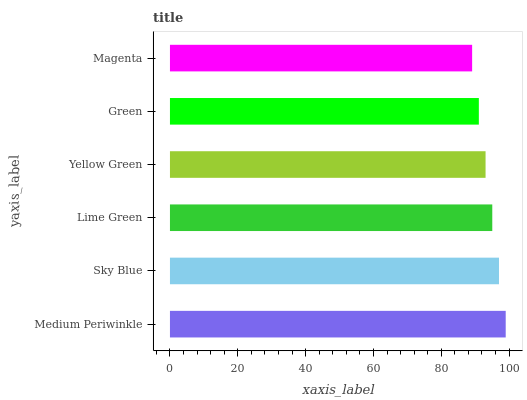Is Magenta the minimum?
Answer yes or no. Yes. Is Medium Periwinkle the maximum?
Answer yes or no. Yes. Is Sky Blue the minimum?
Answer yes or no. No. Is Sky Blue the maximum?
Answer yes or no. No. Is Medium Periwinkle greater than Sky Blue?
Answer yes or no. Yes. Is Sky Blue less than Medium Periwinkle?
Answer yes or no. Yes. Is Sky Blue greater than Medium Periwinkle?
Answer yes or no. No. Is Medium Periwinkle less than Sky Blue?
Answer yes or no. No. Is Lime Green the high median?
Answer yes or no. Yes. Is Yellow Green the low median?
Answer yes or no. Yes. Is Green the high median?
Answer yes or no. No. Is Green the low median?
Answer yes or no. No. 